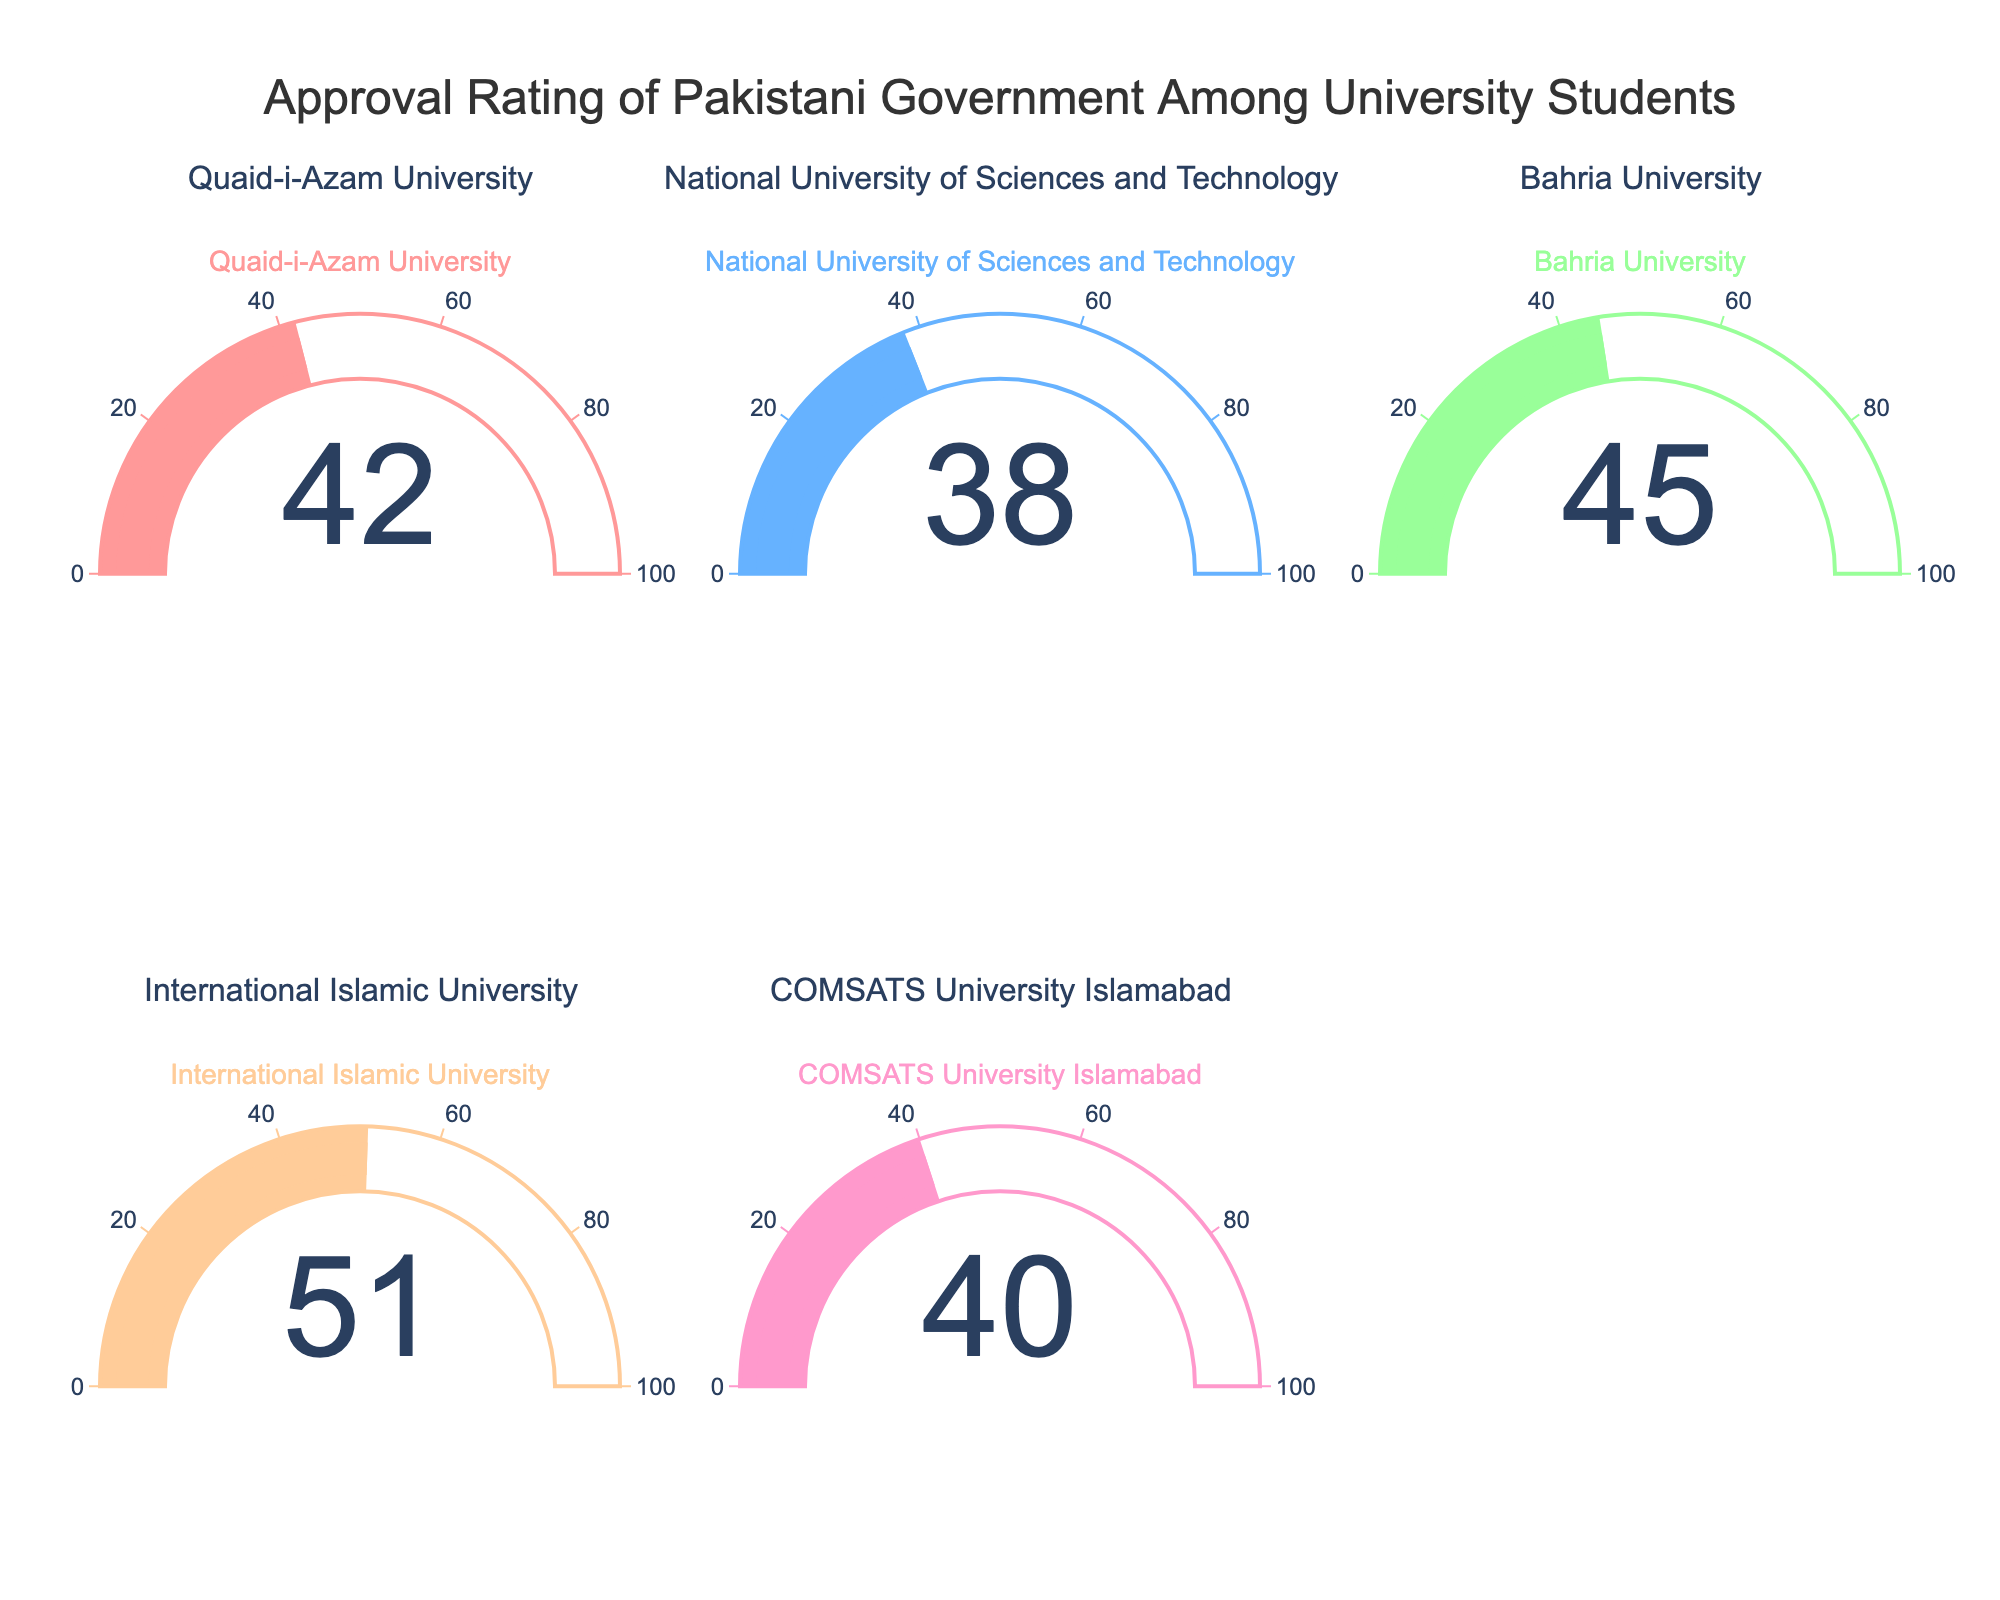How many universities have approval ratings displayed on the figure? By counting the number of gauge charts in the figure, we can determine the number of universities surveyed for their approval ratings.
Answer: 5 Which university has the highest approval rating? Find the gauge with the highest number among the displayed approval ratings.
Answer: International Islamic University What is the difference between the highest and lowest approval ratings? The highest approval rating is 51 (International Islamic University), and the lowest is 38 (National University of Sciences and Technology). The difference between these two values is 51 - 38.
Answer: 13 Which universities have approval ratings above 40? Look at the gauge charts and identify the universities with values greater than 40.
Answer: Quaid-i-Azam University, Bahria University, International Islamic University What is the average approval rating among all universities? Sum the approval ratings of all universities: 42 + 38 + 45 + 51 + 40 = 216. Divide this total by the number of universities (5). The average is 216 / 5.
Answer: 43.2 Are there more universities with approval ratings above 45 or below 45? Count the universities with approval ratings above 45 (International Islamic University) and below 45 (Quaid-i-Azam University, National University of Sciences and Technology, Bahria University, COMSATS University Islamabad).
Answer: Below 45 What is the median approval rating among the universities? Arrange the approval ratings in ascending order: 38, 40, 42, 45, 51. The median is the middle value, which is 42.
Answer: 42 Which university has the second highest approval rating? Identify the second highest number among the approval ratings displayed in the gauge charts.
Answer: Bahria University By how much does the approval rating of COMSATS University Islamabad differ from Quaid-i-Azam University? The approval rating of COMSATS University Islamabad is 40, and Quaid-i-Azam University is 42. The difference is 42 - 40.
Answer: 2 What's the sum of approval ratings for universities with ratings below 45? Sum the approval ratings for Quaid-i-Azam University (42), National University of Sciences and Technology (38), and COMSATS University Islamabad (40). The sum is 42 + 38 + 40.
Answer: 120 